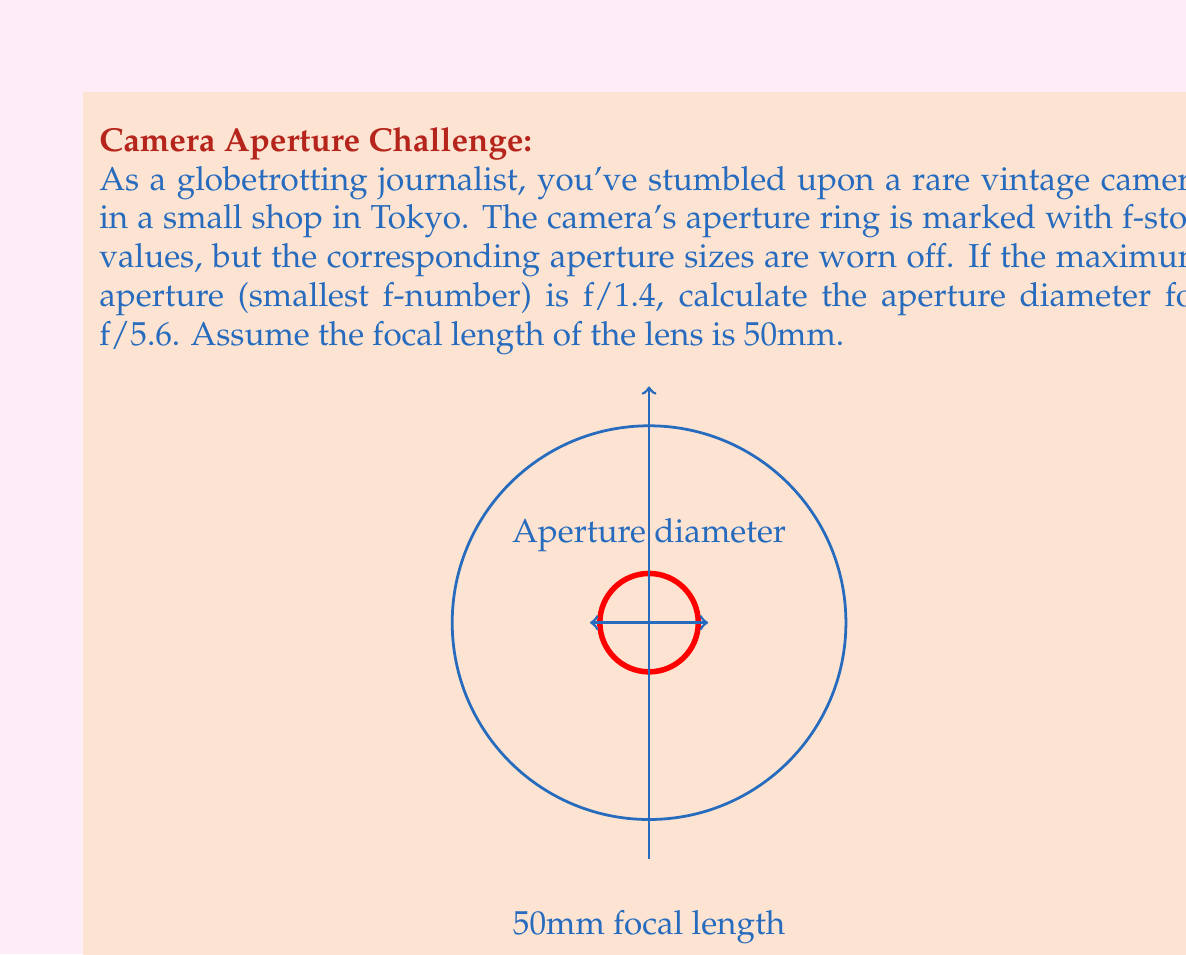Can you answer this question? Let's approach this step-by-step:

1) The f-number (N) is defined as the ratio of the focal length (f) to the aperture diameter (D):

   $$N = \frac{f}{D}$$

2) We're given that the focal length is 50mm, and we want to find the aperture diameter for f/5.6. So:

   $$5.6 = \frac{50mm}{D}$$

3) To solve for D, we multiply both sides by D and divide by 5.6:

   $$D = \frac{50mm}{5.6}$$

4) Now we can calculate:

   $$D = \frac{50}{5.6} \approx 8.93mm$$

5) To verify, let's check if this makes sense. The maximum aperture is f/1.4, which would correspond to:

   $$D_{max} = \frac{50mm}{1.4} \approx 35.71mm$$

   Our calculated aperture for f/5.6 is indeed smaller than this maximum, which is correct.

6) As an interesting note for a camera enthusiast, each full f-stop represents a halving/doubling of the light entering the camera. The sequence f/1.4 → f/2 → f/2.8 → f/4 → f/5.6 represents this halving of light at each step.
Answer: $8.93mm$ 